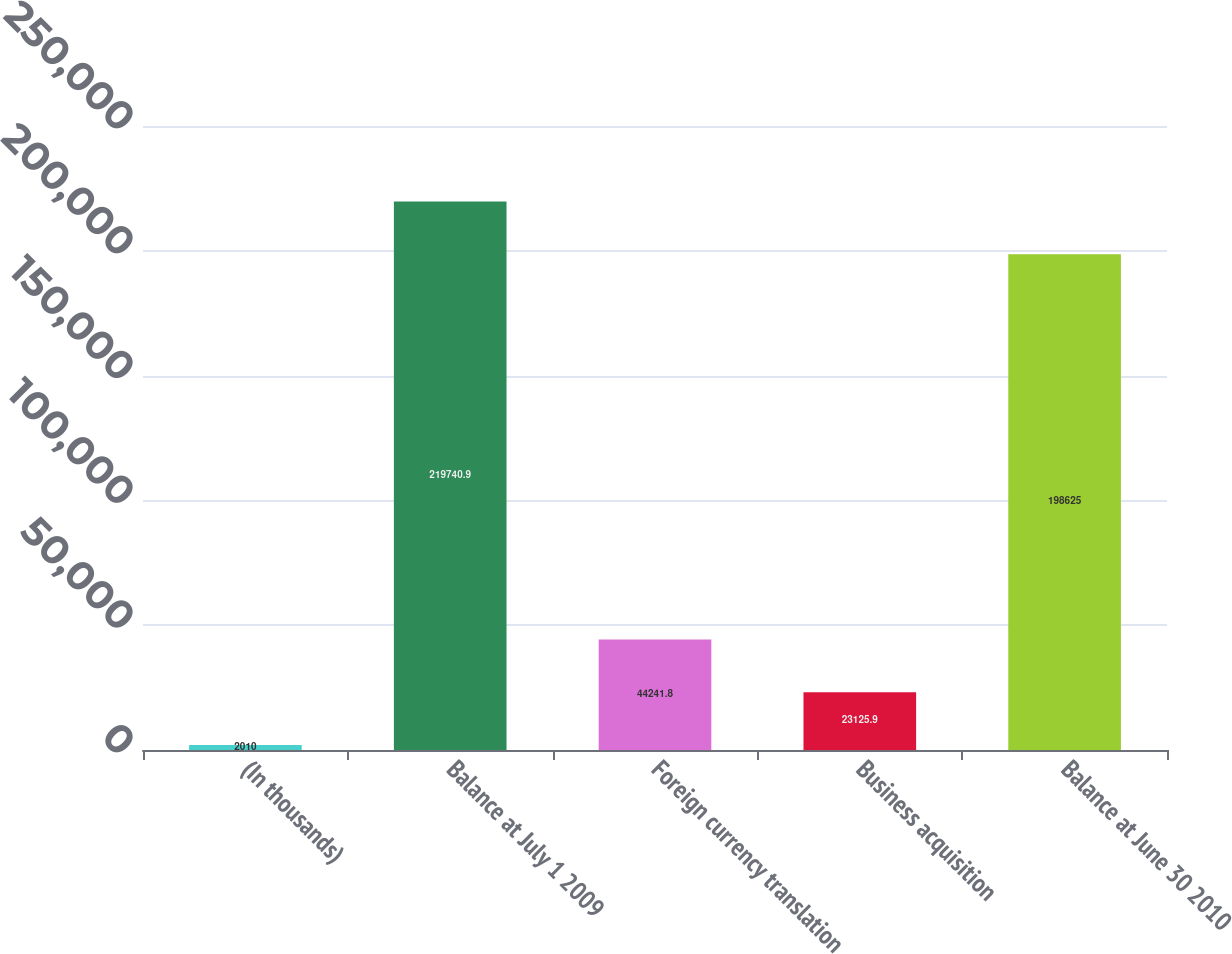<chart> <loc_0><loc_0><loc_500><loc_500><bar_chart><fcel>(In thousands)<fcel>Balance at July 1 2009<fcel>Foreign currency translation<fcel>Business acquisition<fcel>Balance at June 30 2010<nl><fcel>2010<fcel>219741<fcel>44241.8<fcel>23125.9<fcel>198625<nl></chart> 